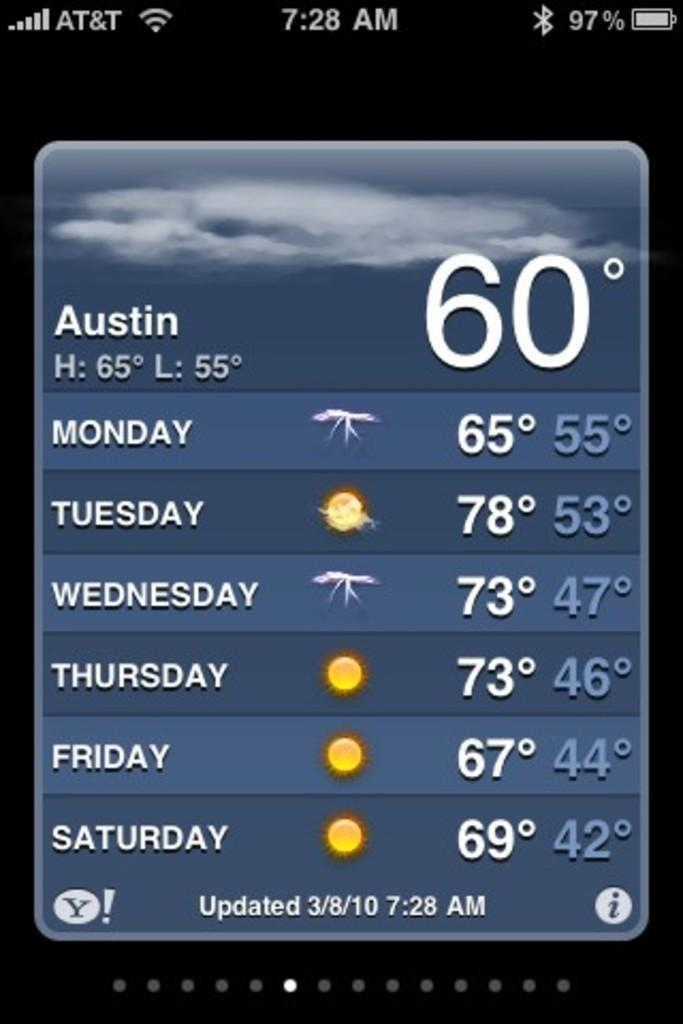<image>
Give a short and clear explanation of the subsequent image. A phone screen shows that the weather in Austin is 60 degrees right now. 